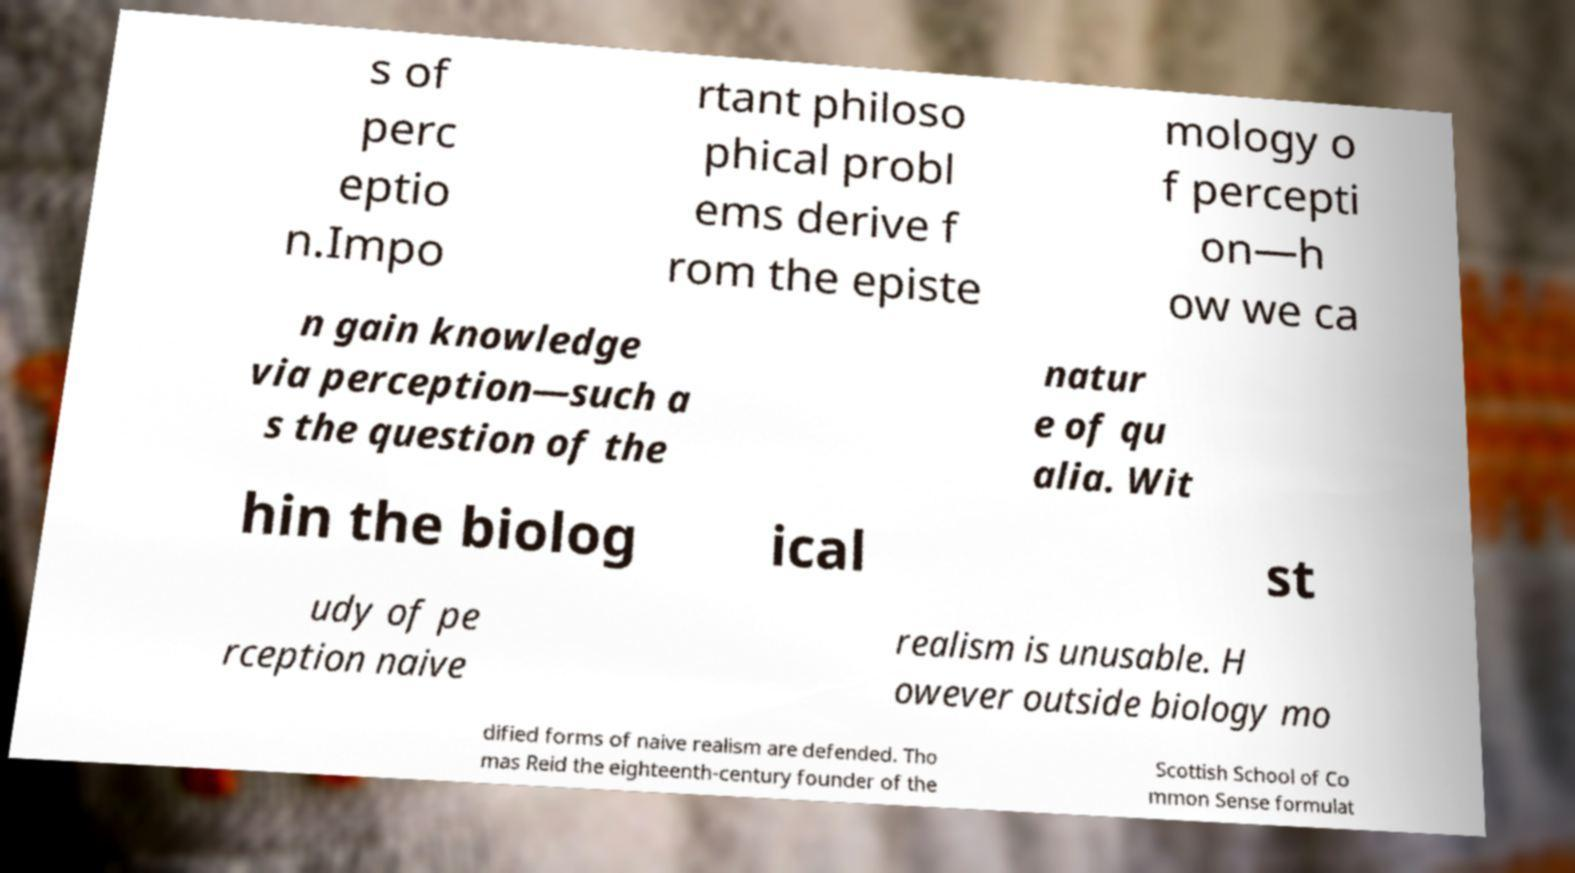Can you read and provide the text displayed in the image?This photo seems to have some interesting text. Can you extract and type it out for me? s of perc eptio n.Impo rtant philoso phical probl ems derive f rom the episte mology o f percepti on—h ow we ca n gain knowledge via perception—such a s the question of the natur e of qu alia. Wit hin the biolog ical st udy of pe rception naive realism is unusable. H owever outside biology mo dified forms of naive realism are defended. Tho mas Reid the eighteenth-century founder of the Scottish School of Co mmon Sense formulat 